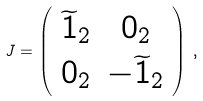<formula> <loc_0><loc_0><loc_500><loc_500>J = \left ( \begin{array} { c c } \widetilde { 1 } _ { 2 } & 0 _ { 2 } \\ 0 _ { 2 } & - \widetilde { 1 } _ { 2 } \end{array} \right ) \, ,</formula> 